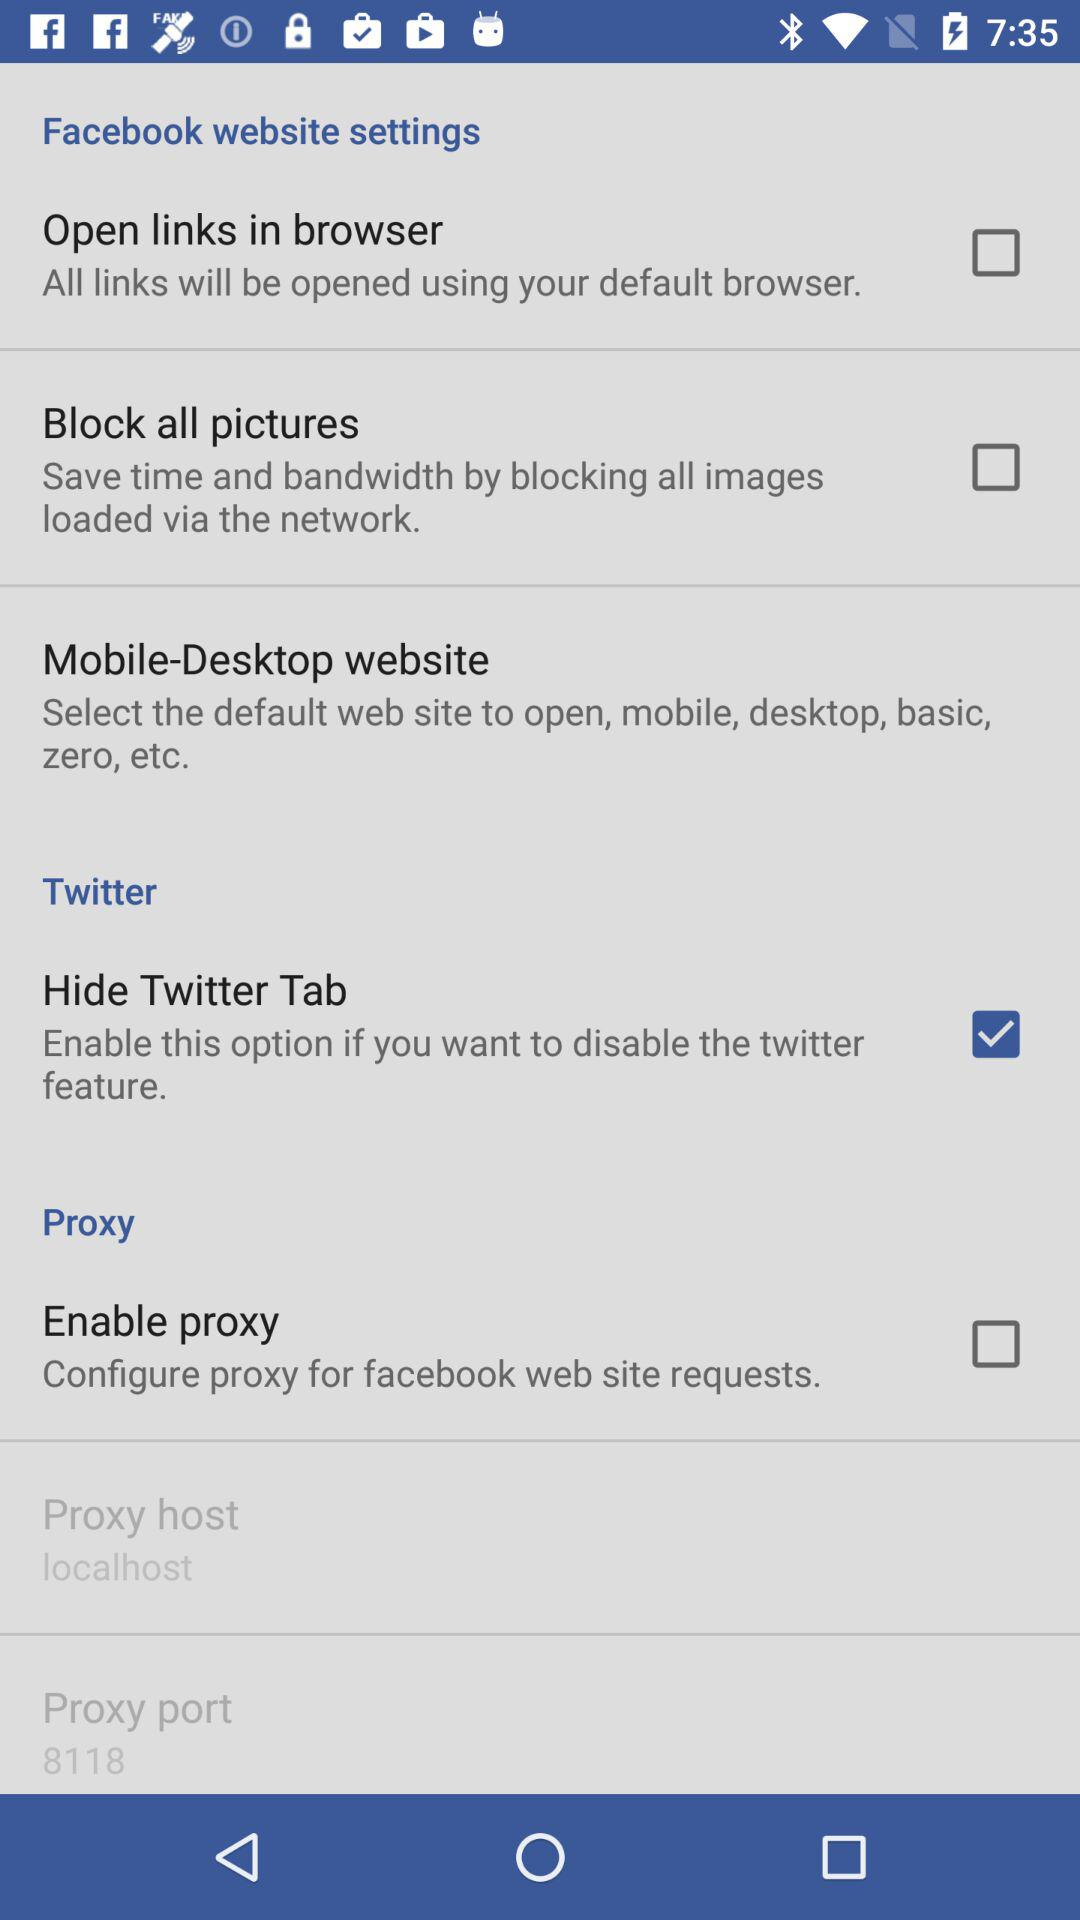What is the status of the "Block all pictures"? The status of the "Block all pictures" is "off". 